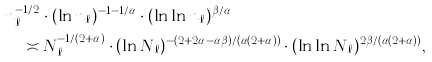<formula> <loc_0><loc_0><loc_500><loc_500>& n _ { \ell } ^ { - 1 / 2 } \cdot ( \ln n _ { \ell } ) ^ { - 1 - 1 / \alpha } \cdot ( \ln \ln n _ { \ell } ) ^ { \beta / \alpha } \\ & \quad \asymp N _ { \ell } ^ { - 1 / ( 2 + \alpha ) } \cdot ( \ln N _ { \ell } ) ^ { - ( 2 + 2 \alpha - \alpha \beta ) / ( \alpha ( 2 + \alpha ) ) } \cdot ( \ln \ln N _ { \ell } ) ^ { 2 \beta / ( \alpha ( 2 + \alpha ) ) } ,</formula> 